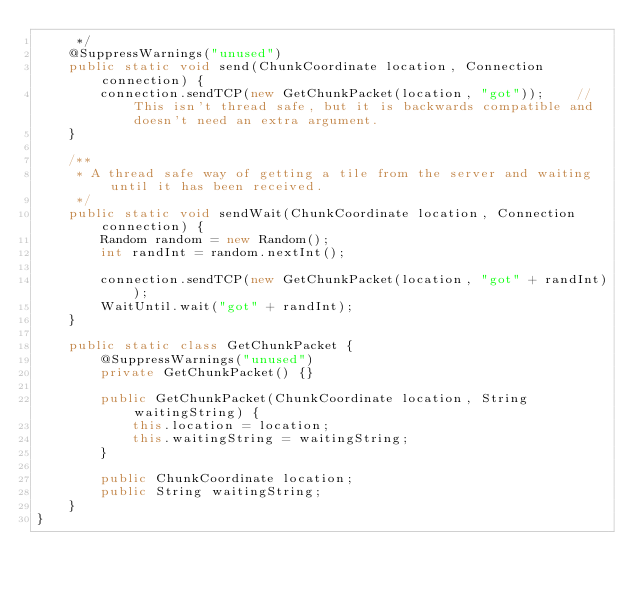Convert code to text. <code><loc_0><loc_0><loc_500><loc_500><_Java_>	 */
	@SuppressWarnings("unused")
	public static void send(ChunkCoordinate location, Connection connection) {
		connection.sendTCP(new GetChunkPacket(location, "got"));	// This isn't thread safe, but it is backwards compatible and doesn't need an extra argument.
	}

	/**
	 * A thread safe way of getting a tile from the server and waiting until it has been received.
	 */
	public static void sendWait(ChunkCoordinate location, Connection connection) {
		Random random = new Random();
		int randInt = random.nextInt();

		connection.sendTCP(new GetChunkPacket(location, "got" + randInt));
		WaitUntil.wait("got" + randInt);
	}

	public static class GetChunkPacket {
		@SuppressWarnings("unused")
		private GetChunkPacket() {}

		public GetChunkPacket(ChunkCoordinate location, String waitingString) {
			this.location = location;
			this.waitingString = waitingString;
		}

		public ChunkCoordinate location;
		public String waitingString;
	}
}
</code> 